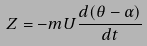Convert formula to latex. <formula><loc_0><loc_0><loc_500><loc_500>Z = - m U \frac { d ( \theta - \alpha ) } { d t }</formula> 